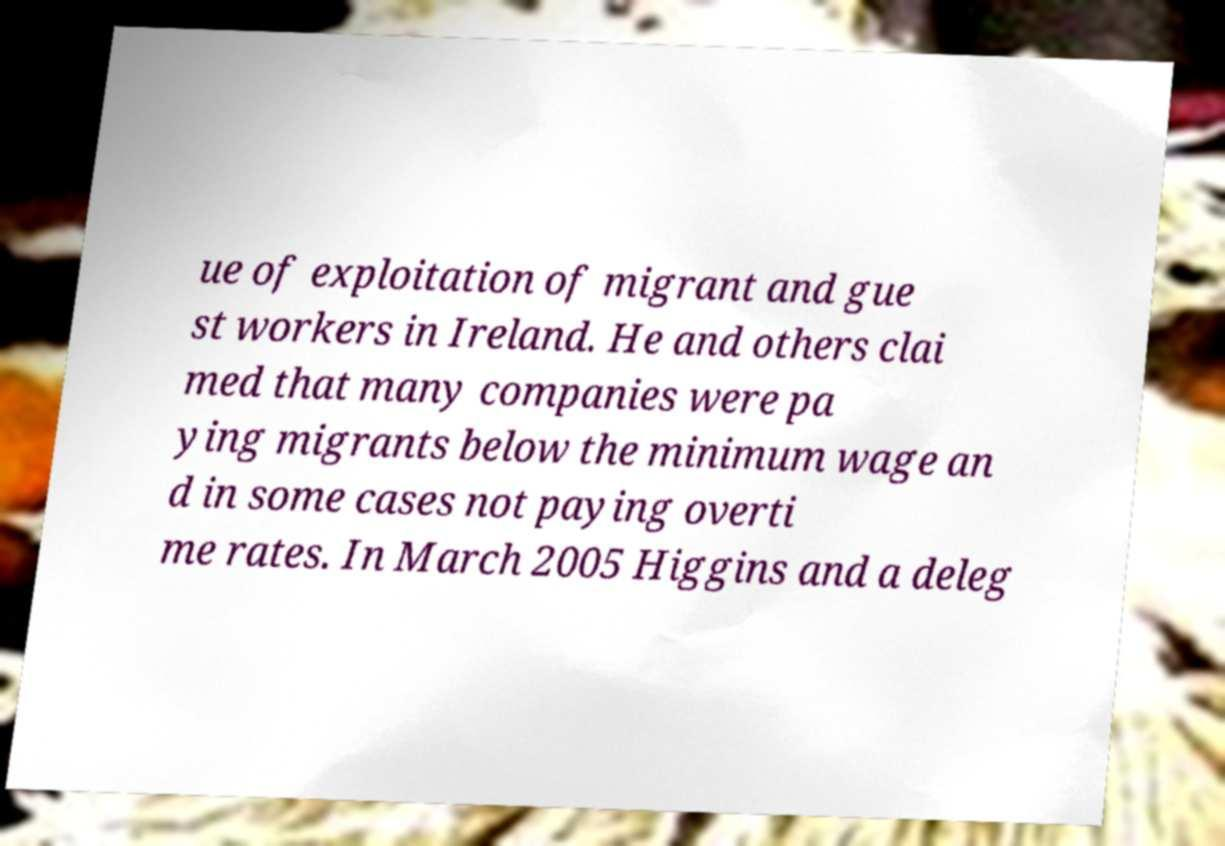Please identify and transcribe the text found in this image. ue of exploitation of migrant and gue st workers in Ireland. He and others clai med that many companies were pa ying migrants below the minimum wage an d in some cases not paying overti me rates. In March 2005 Higgins and a deleg 